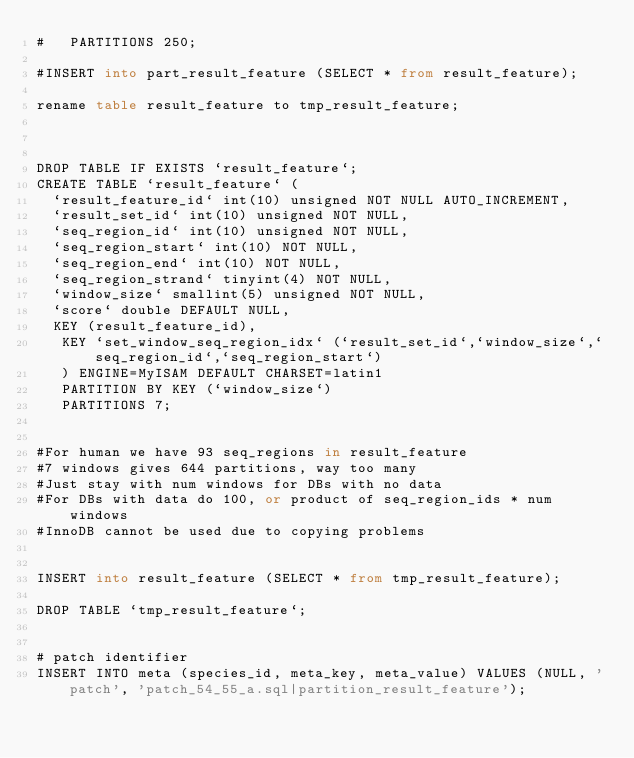<code> <loc_0><loc_0><loc_500><loc_500><_SQL_>#   PARTITIONS 250;

#INSERT into part_result_feature (SELECT * from result_feature);

rename table result_feature to tmp_result_feature;



DROP TABLE IF EXISTS `result_feature`;
CREATE TABLE `result_feature` (
  `result_feature_id` int(10) unsigned NOT NULL AUTO_INCREMENT,
  `result_set_id` int(10) unsigned NOT NULL,
  `seq_region_id` int(10) unsigned NOT NULL,
  `seq_region_start` int(10) NOT NULL,
  `seq_region_end` int(10) NOT NULL,
  `seq_region_strand` tinyint(4) NOT NULL,
  `window_size` smallint(5) unsigned NOT NULL,
  `score` double DEFAULT NULL,
	KEY (result_feature_id),
   KEY `set_window_seq_region_idx` (`result_set_id`,`window_size`,`seq_region_id`,`seq_region_start`)
   ) ENGINE=MyISAM DEFAULT CHARSET=latin1 
   PARTITION BY KEY (`window_size`)
   PARTITIONS 7;


#For human we have 93 seq_regions in result_feature
#7 windows gives 644 partitions, way too many
#Just stay with num windows for DBs with no data
#For DBs with data do 100, or product of seq_region_ids * num windows
#InnoDB cannot be used due to copying problems


INSERT into result_feature (SELECT * from tmp_result_feature);

DROP TABLE `tmp_result_feature`;


# patch identifier
INSERT INTO meta (species_id, meta_key, meta_value) VALUES (NULL, 'patch', 'patch_54_55_a.sql|partition_result_feature');


</code> 